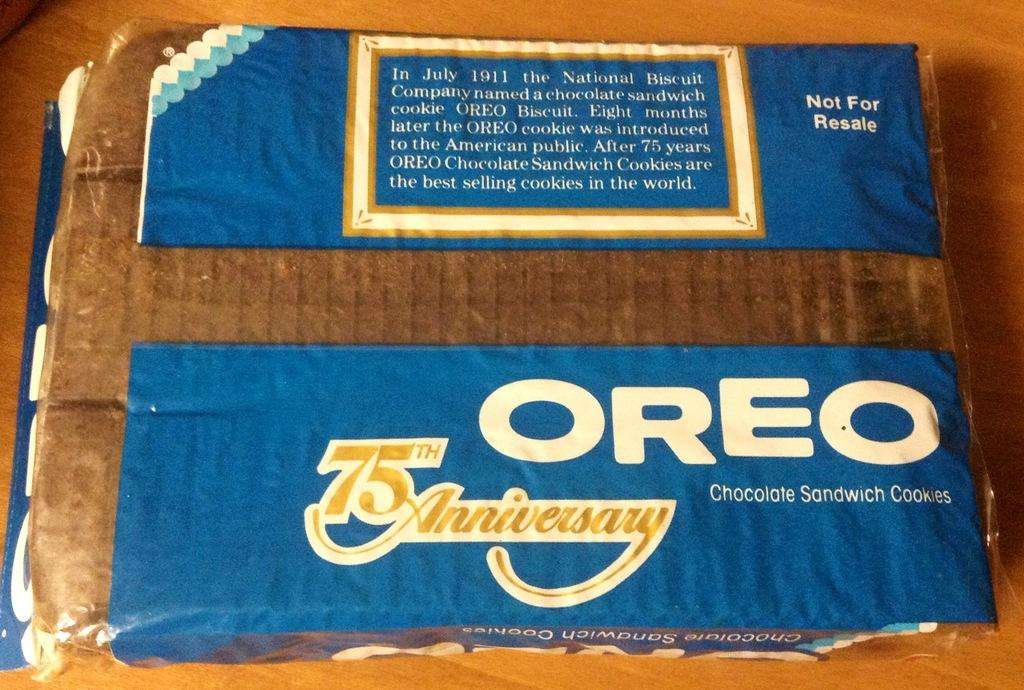What is the main object in the image? There is a biscuit packet in the image. What can be found on the biscuit packet? There is text on the biscuit packet. What type of snake is wrapped around the biscuit packet in the image? There is no snake present in the image; it only features a biscuit packet with text on it. 